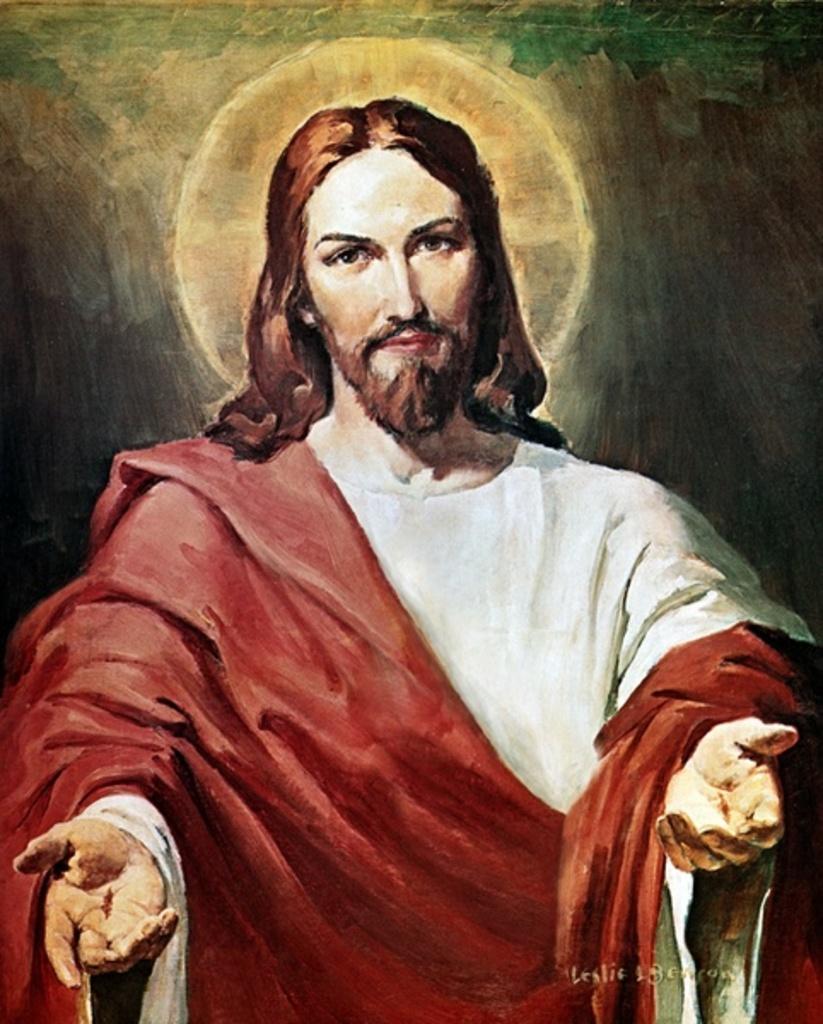Describe this image in one or two sentences. There is a painting in which, there is a person in white color dress having a red color cloth on his shoulder and hand and stretching his hands. In the background, there is a moon in the sky. And the background is dark in color. 